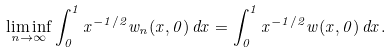<formula> <loc_0><loc_0><loc_500><loc_500>\liminf _ { n \to \infty } \int _ { 0 } ^ { 1 } x ^ { - 1 / 2 } w _ { n } ( x , 0 ) \, d x = \int _ { 0 } ^ { 1 } x ^ { - 1 / 2 } w ( x , 0 ) \, d x .</formula> 